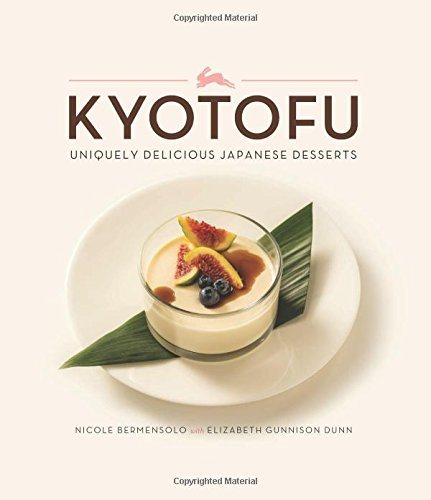Is this book related to Medical Books? No, this book is not related to the Medical Books category. It primarily focuses on culinary arts, specifically Japanese desserts. 